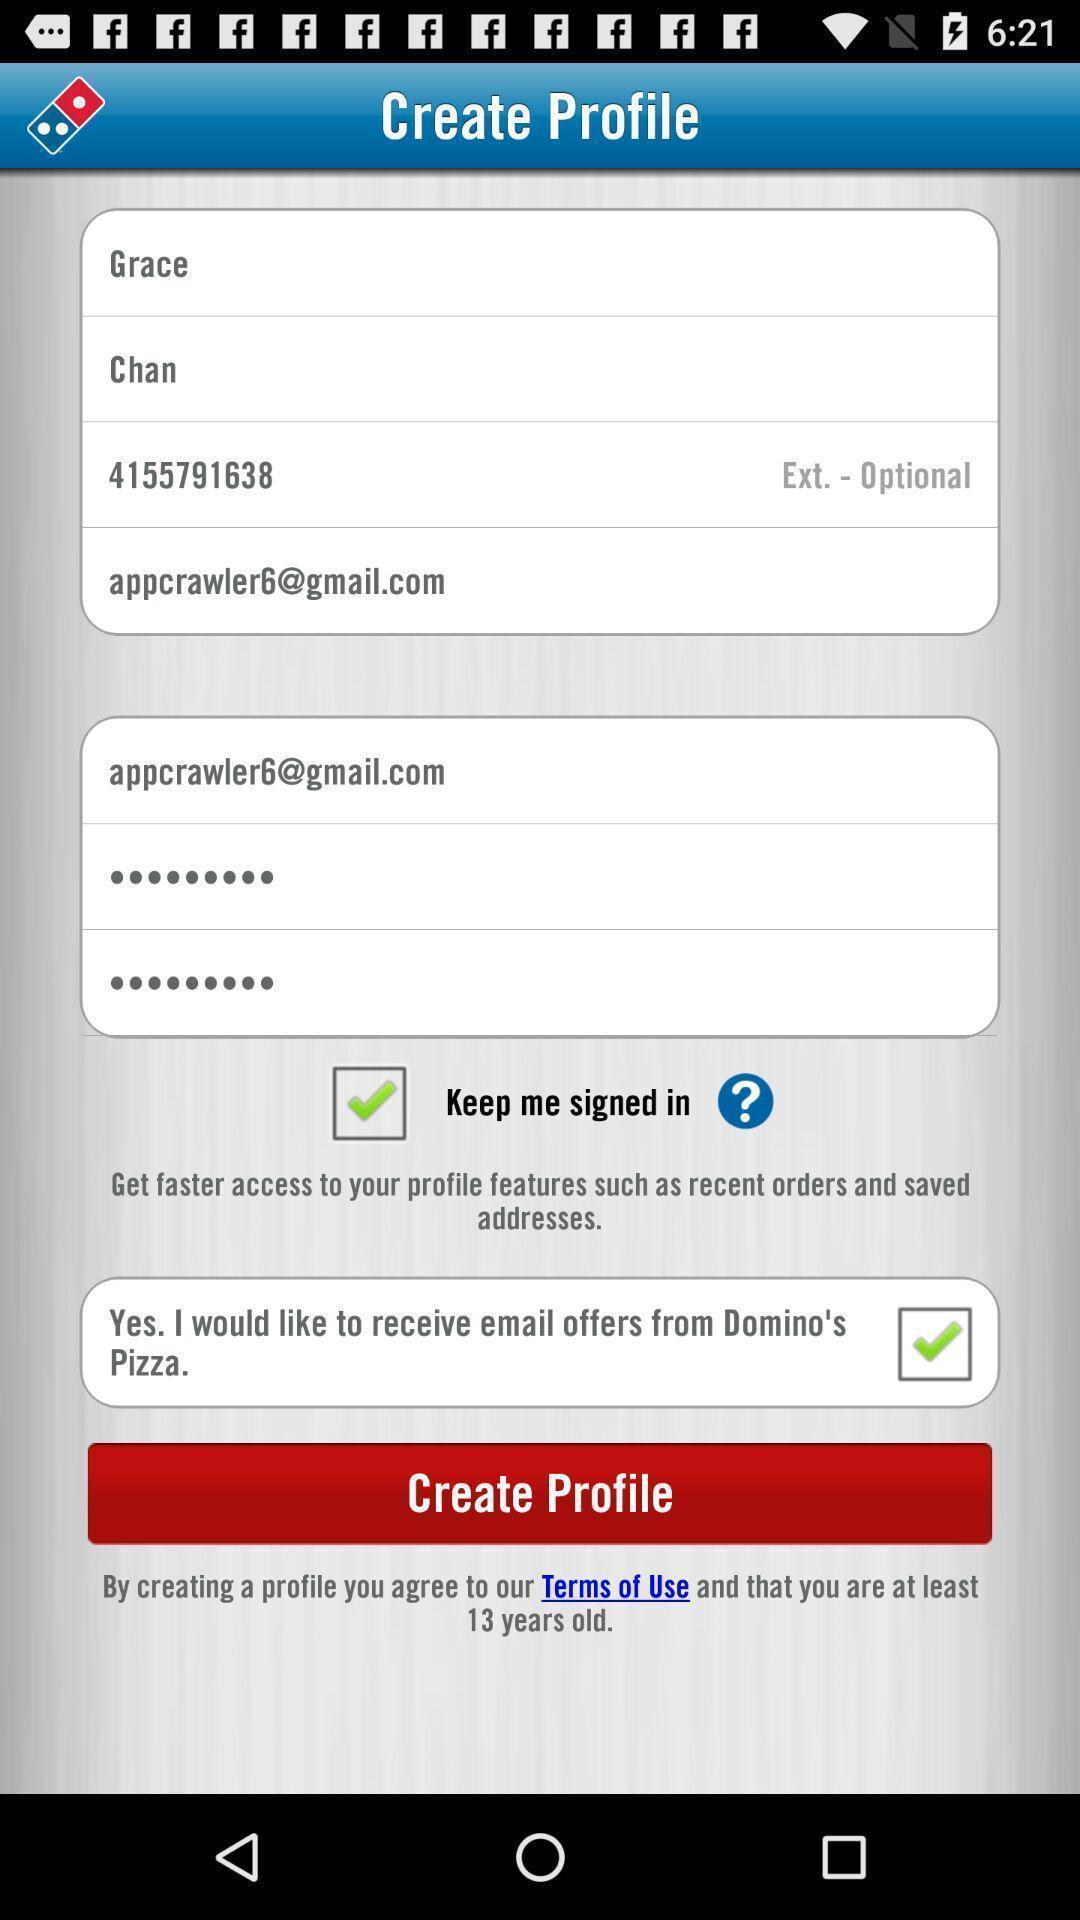Explain what's happening in this screen capture. Sign up page. 